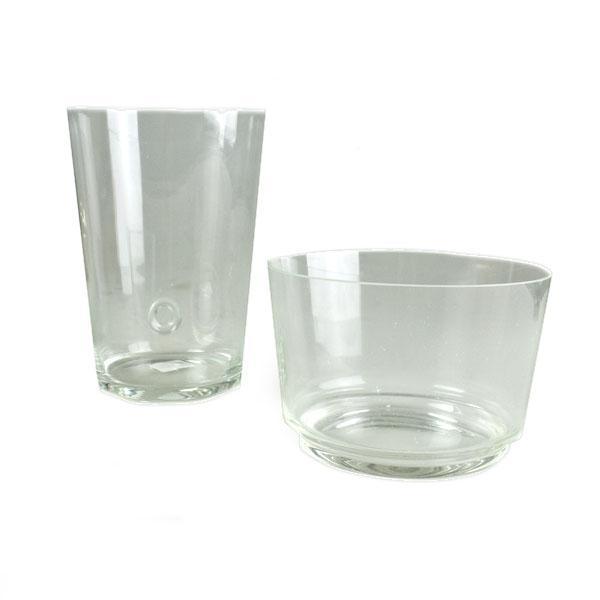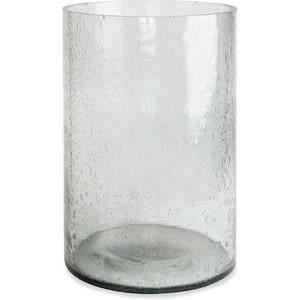The first image is the image on the left, the second image is the image on the right. Analyze the images presented: Is the assertion "All photos have exactly three vases or jars positioned in close proximity to each other." valid? Answer yes or no. No. The first image is the image on the left, the second image is the image on the right. Examine the images to the left and right. Is the description "all vases have muted colors and some with flowers" accurate? Answer yes or no. No. 